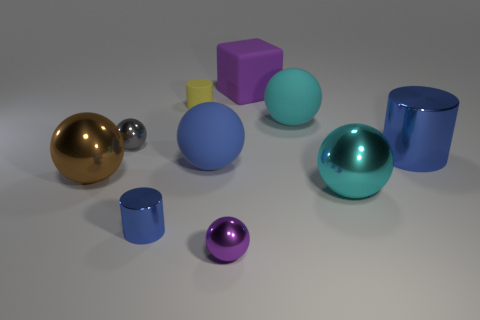How many objects are there in the image, and can you describe the different shapes present? There are nine objects in the image, comprising various shapes. You can see spheres, cylinders, a cube, and an elongated cuboid, all rendered with smooth surfaces and placed casually as if they are part of a set. 